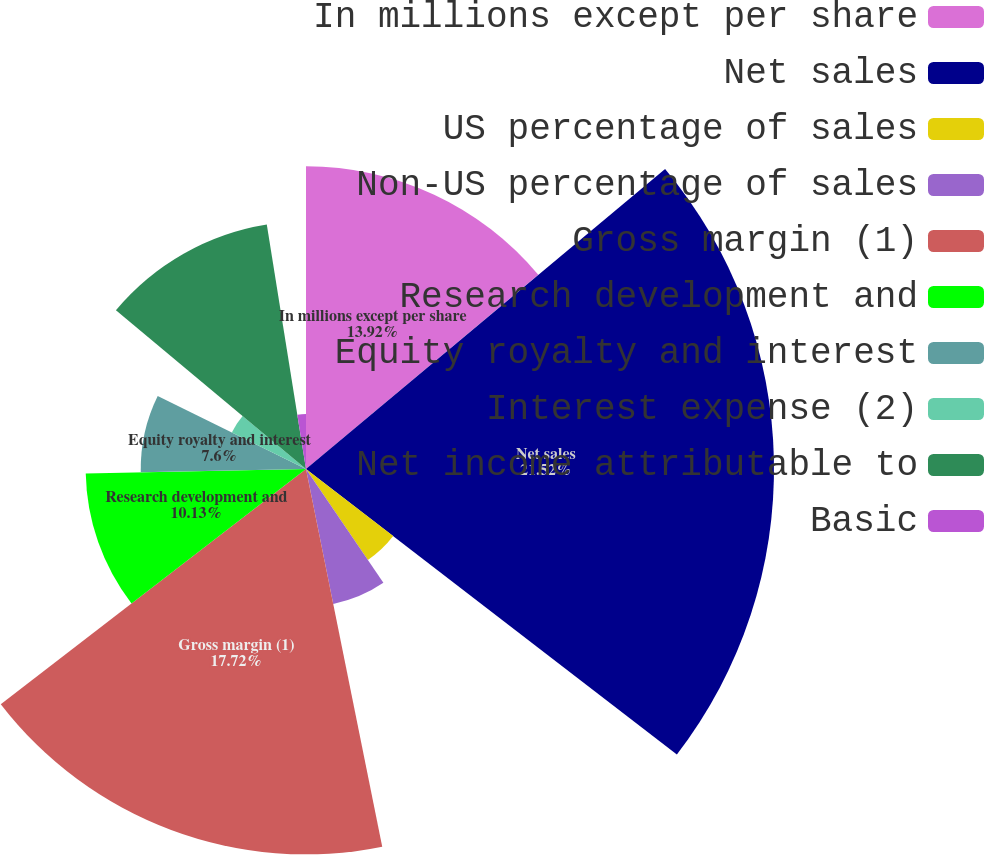<chart> <loc_0><loc_0><loc_500><loc_500><pie_chart><fcel>In millions except per share<fcel>Net sales<fcel>US percentage of sales<fcel>Non-US percentage of sales<fcel>Gross margin (1)<fcel>Research development and<fcel>Equity royalty and interest<fcel>Interest expense (2)<fcel>Net income attributable to<fcel>Basic<nl><fcel>13.92%<fcel>21.52%<fcel>5.06%<fcel>6.33%<fcel>17.72%<fcel>10.13%<fcel>7.6%<fcel>3.8%<fcel>11.39%<fcel>2.53%<nl></chart> 